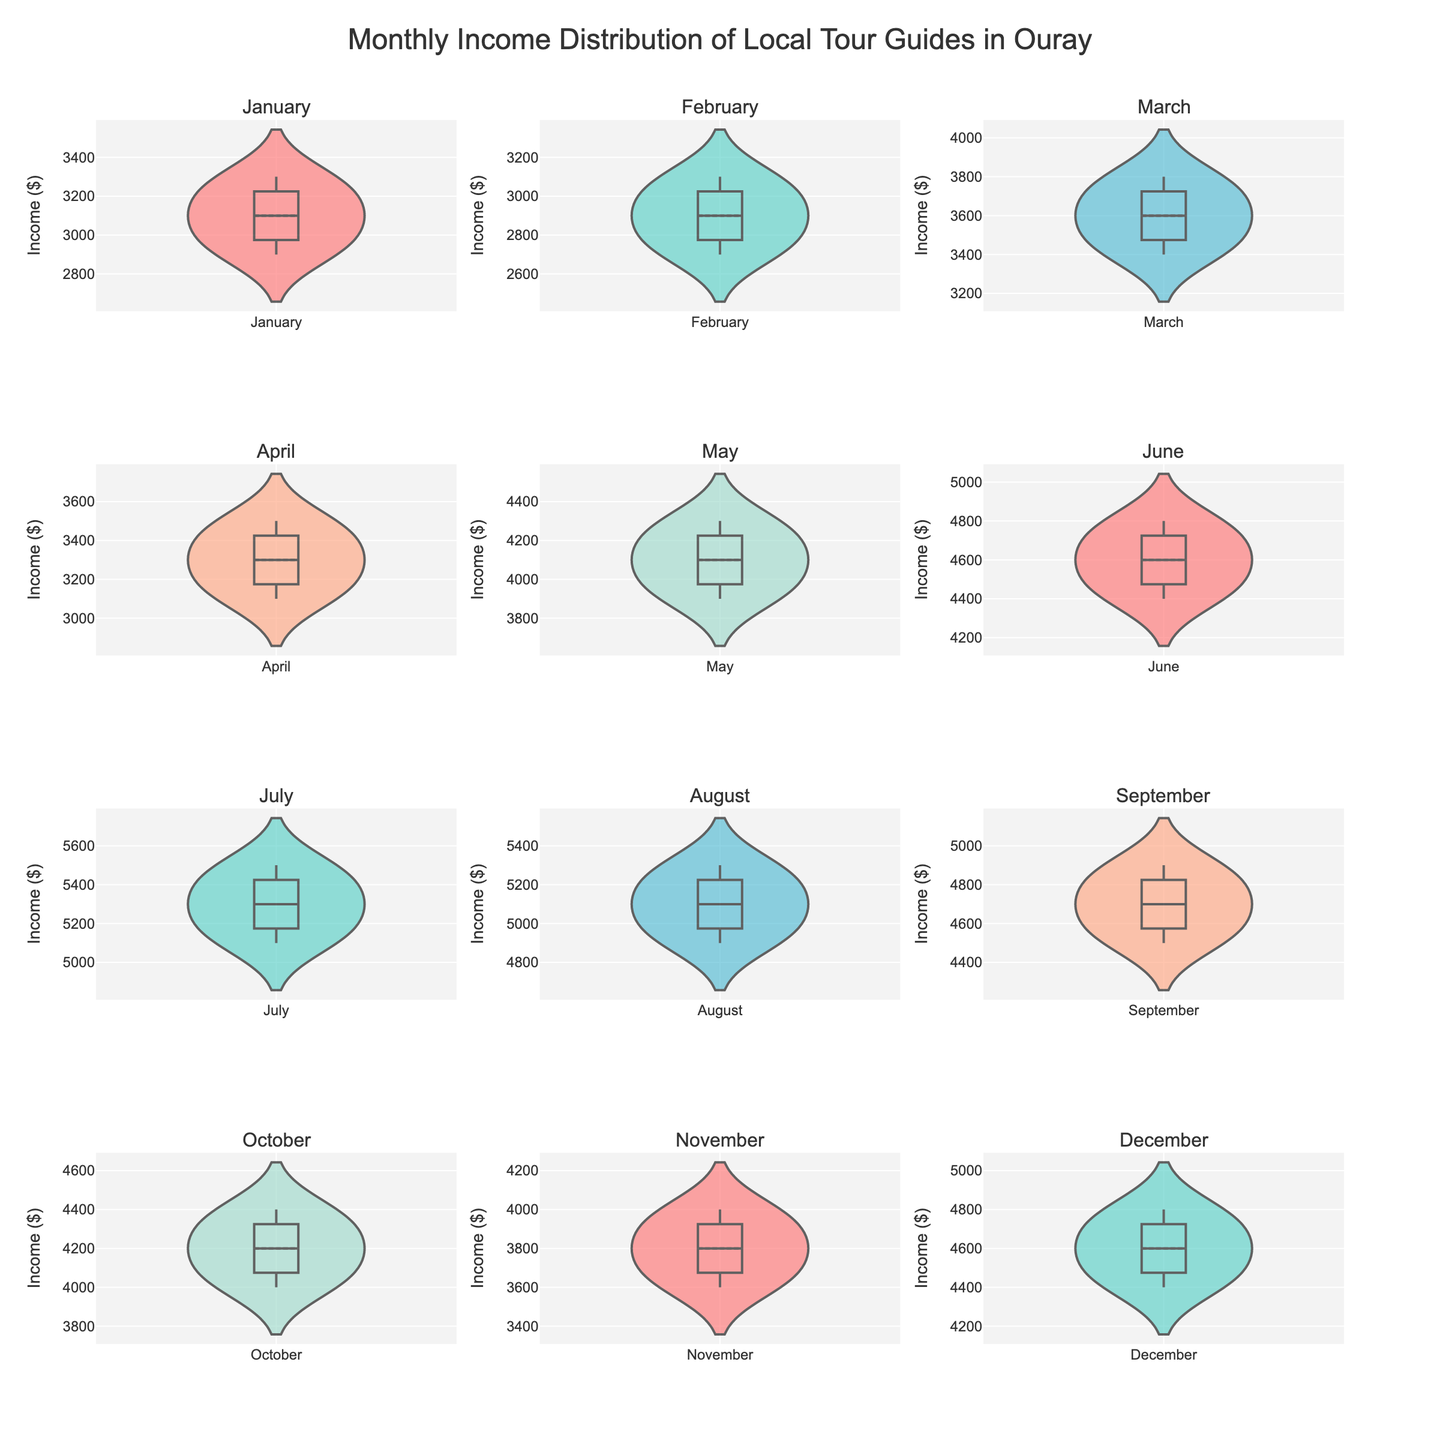what is the title of the figure? The title of the figure is displayed at the top of the plot. It is often used to give viewers an idea of what the data represents
Answer: Monthly Income Distribution of Local Tour Guides in Ouray Which month appears to have the highest median income for local tour guides? To answer this question, one must look at the median lines in each of the monthly violin plots and identify which is highest
Answer: July How does the range of income in April compare to that in September? Look at the spread of the violin plots for April and September. The range is the distance between the top and bottom extremes
Answer: The income range is narrower in April compared to September Which month's income distribution shows the least range? Determine which violin plot has the shortest length from top to bottom, indicating the smallest difference between the highest and lowest incomes
Answer: January In which month do local tour guides have the most variable incomes? The variability is indicated by the width of the violin plots. Wider plots imply more spread-out data, i.e., higher variability
Answer: July What's the mean income in December and how is it represented in the chart? Locate the mean line within the December violin plot. This line indicates the central tendency of the income data
Answer: The mean income in December is highlighted by a dashed or solid line at approximately $4600 Is there a visible trend in the monthly income distribution of the local tour guides throughout the year? Observe the median lines across all months and note their positioning. A consistent increase or decrease might indicate a trend
Answer: Yes, there is a visible increasing trend, peaking around mid-year Which month has the smallest income outliers? Compare the plots to see which has the fewest or smallest outlier points outside the main body of the violin plot
Answer: April Describe the income distribution trend from January to June. Observe the position and shape of the violins from January to June to identify any trend or pattern over these months
Answer: Incomes steadily increase from January to June How does the income distribution in July compare to that in May? Compare both violin plots in terms of median, range, and spread to understand the differences between these two months
Answer: July has higher median and wider distribution than May 